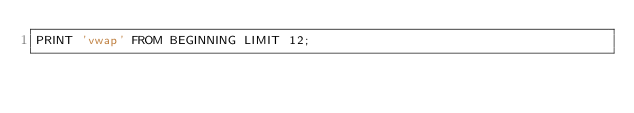<code> <loc_0><loc_0><loc_500><loc_500><_SQL_>PRINT 'vwap' FROM BEGINNING LIMIT 12;</code> 